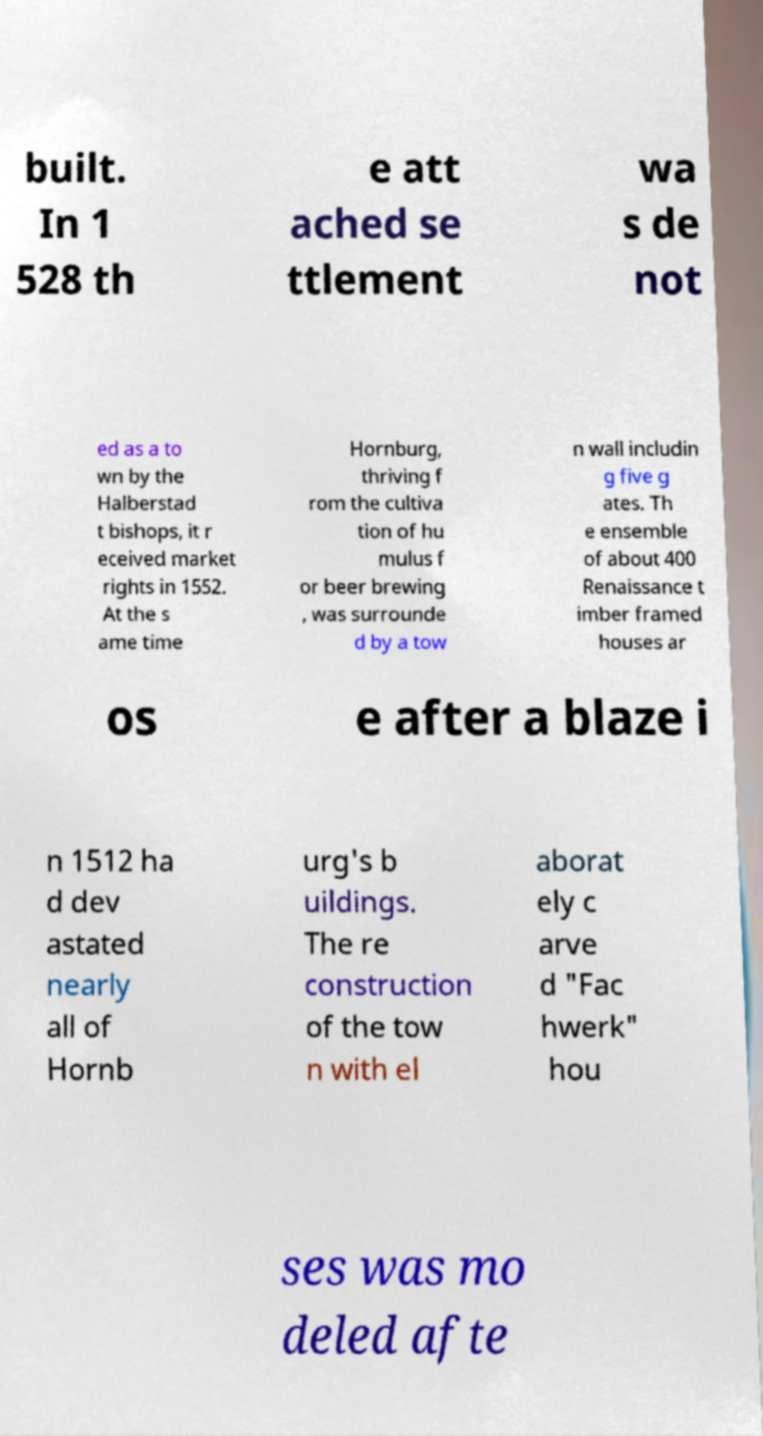I need the written content from this picture converted into text. Can you do that? built. In 1 528 th e att ached se ttlement wa s de not ed as a to wn by the Halberstad t bishops, it r eceived market rights in 1552. At the s ame time Hornburg, thriving f rom the cultiva tion of hu mulus f or beer brewing , was surrounde d by a tow n wall includin g five g ates. Th e ensemble of about 400 Renaissance t imber framed houses ar os e after a blaze i n 1512 ha d dev astated nearly all of Hornb urg's b uildings. The re construction of the tow n with el aborat ely c arve d "Fac hwerk" hou ses was mo deled afte 